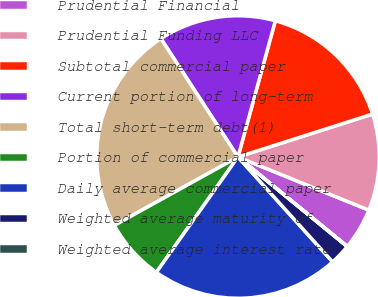Convert chart. <chart><loc_0><loc_0><loc_500><loc_500><pie_chart><fcel>Prudential Financial<fcel>Prudential Funding LLC<fcel>Subtotal commercial paper<fcel>Current portion of long-term<fcel>Total short-term debt(1)<fcel>Portion of commercial paper<fcel>Daily average commercial paper<fcel>Weighted average maturity of<fcel>Weighted average interest rate<nl><fcel>4.78%<fcel>11.05%<fcel>15.82%<fcel>13.44%<fcel>23.86%<fcel>7.16%<fcel>21.48%<fcel>2.39%<fcel>0.01%<nl></chart> 